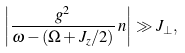Convert formula to latex. <formula><loc_0><loc_0><loc_500><loc_500>\left | \frac { g ^ { 2 } } { \omega - ( \Omega + J _ { z } / 2 ) } \, n \right | \gg J _ { \perp } ,</formula> 